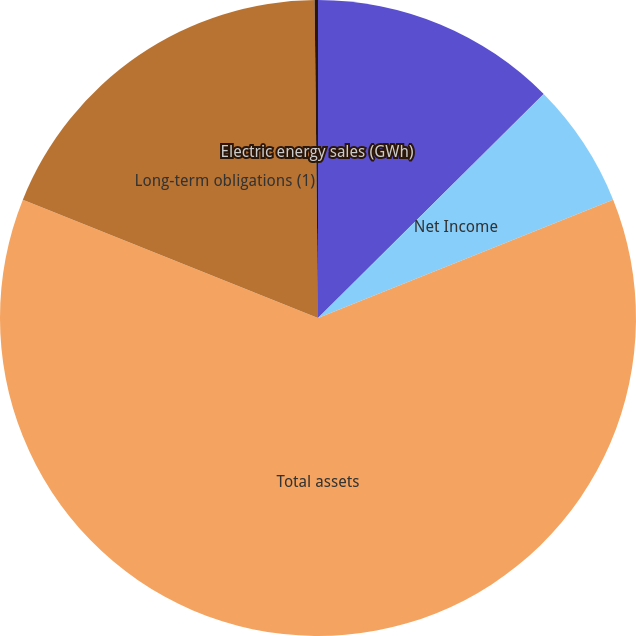Convert chart. <chart><loc_0><loc_0><loc_500><loc_500><pie_chart><fcel>Operating revenues<fcel>Net Income<fcel>Total assets<fcel>Long-term obligations (1)<fcel>Electric energy sales (GWh)<nl><fcel>12.56%<fcel>6.37%<fcel>62.14%<fcel>18.76%<fcel>0.17%<nl></chart> 